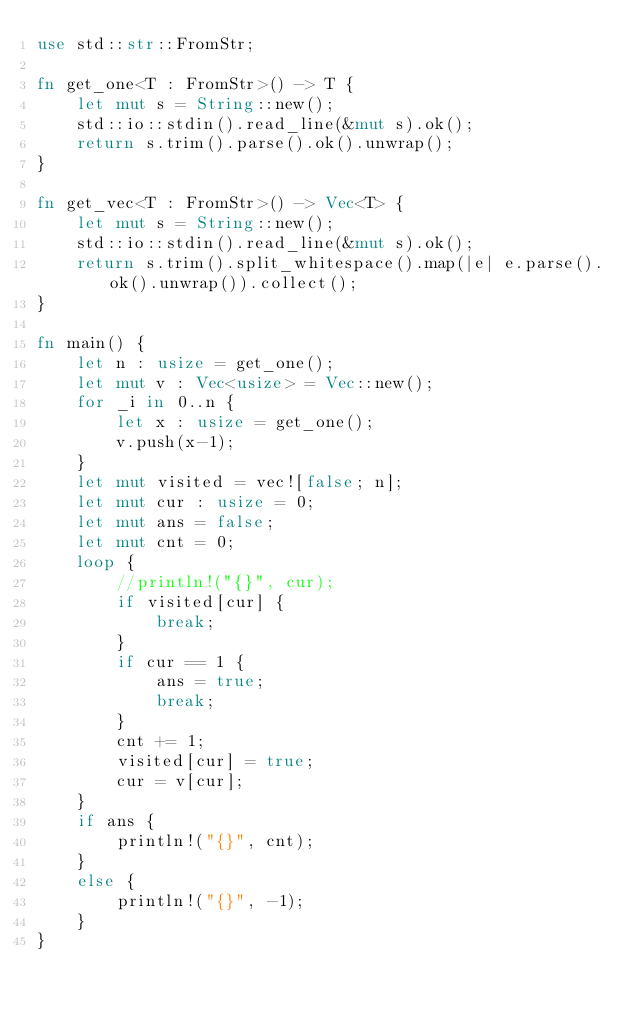Convert code to text. <code><loc_0><loc_0><loc_500><loc_500><_Rust_>use std::str::FromStr;

fn get_one<T : FromStr>() -> T {
    let mut s = String::new();
    std::io::stdin().read_line(&mut s).ok();
    return s.trim().parse().ok().unwrap();
}

fn get_vec<T : FromStr>() -> Vec<T> {
    let mut s = String::new();
    std::io::stdin().read_line(&mut s).ok();
    return s.trim().split_whitespace().map(|e| e.parse().ok().unwrap()).collect();
}

fn main() {
    let n : usize = get_one();
    let mut v : Vec<usize> = Vec::new();
    for _i in 0..n {
        let x : usize = get_one();
        v.push(x-1);
    }
    let mut visited = vec![false; n];
    let mut cur : usize = 0;
    let mut ans = false;
    let mut cnt = 0;
    loop {
        //println!("{}", cur);
        if visited[cur] {
            break;
        }
        if cur == 1 {
            ans = true;
            break;
        }
        cnt += 1;
        visited[cur] = true;
        cur = v[cur];
    }
    if ans {
        println!("{}", cnt);
    }
    else {
        println!("{}", -1);
    }
}
</code> 